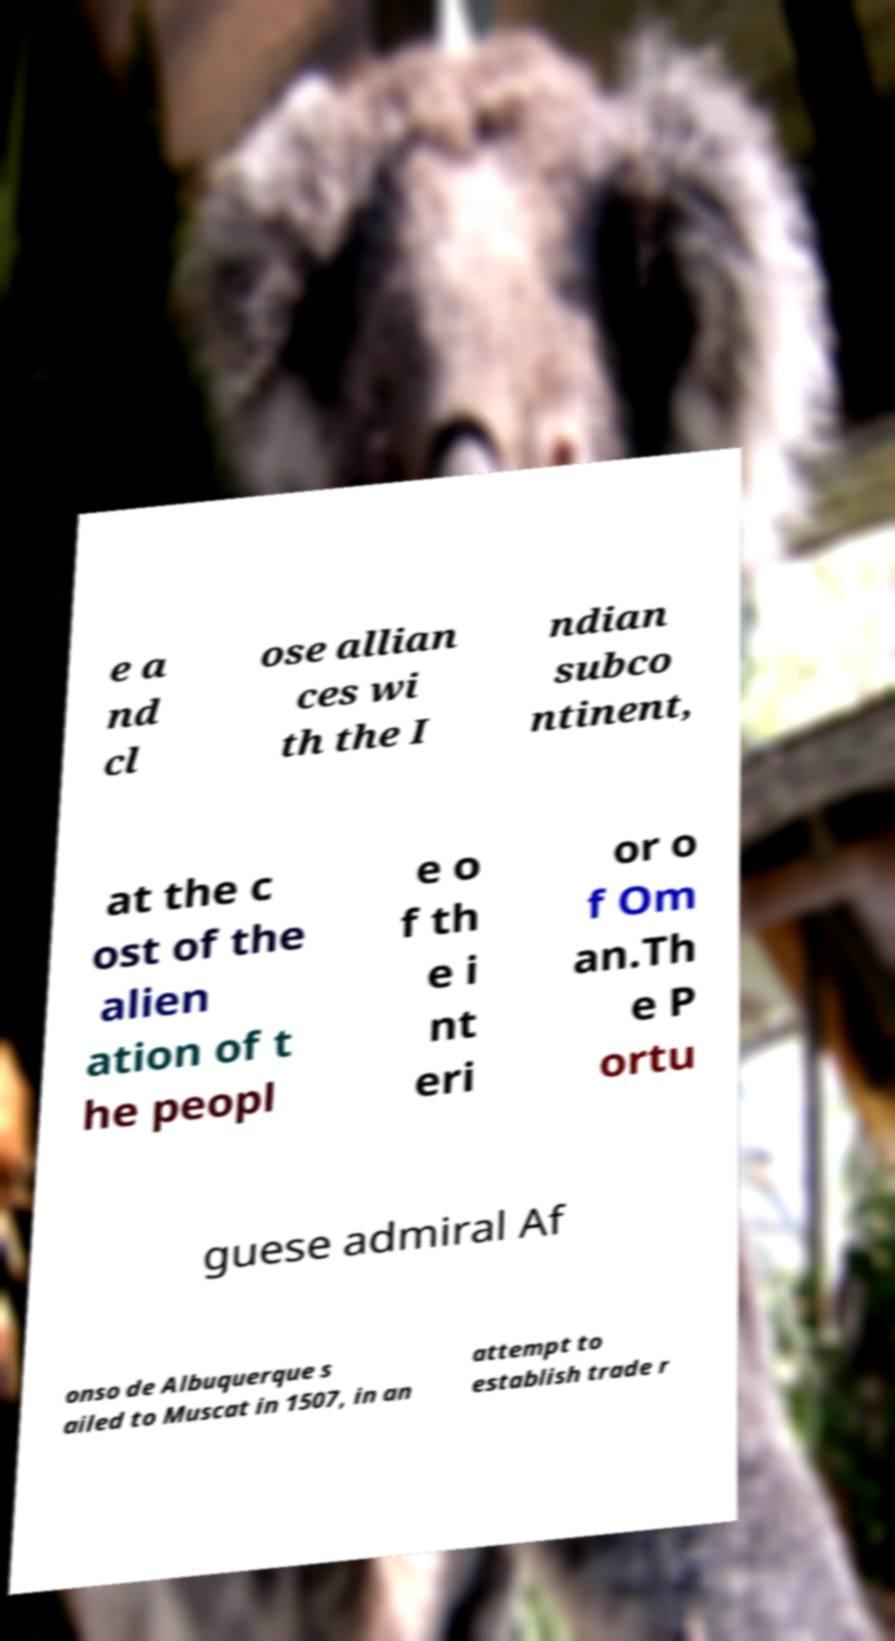Can you accurately transcribe the text from the provided image for me? e a nd cl ose allian ces wi th the I ndian subco ntinent, at the c ost of the alien ation of t he peopl e o f th e i nt eri or o f Om an.Th e P ortu guese admiral Af onso de Albuquerque s ailed to Muscat in 1507, in an attempt to establish trade r 